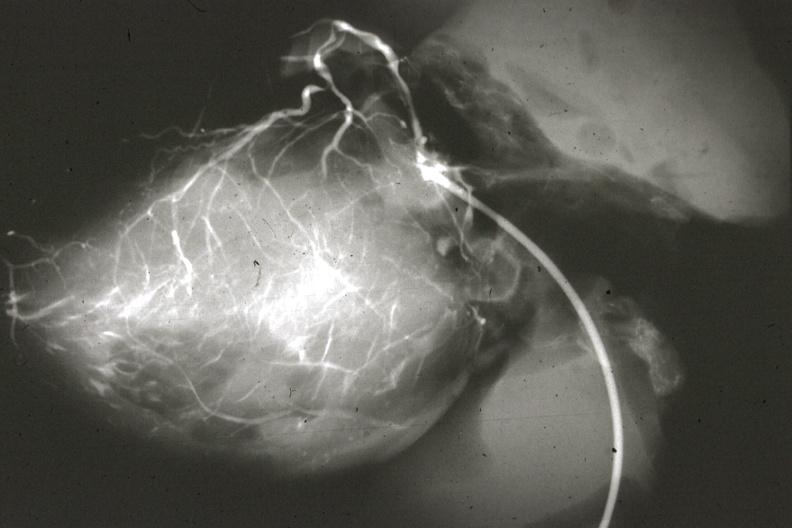s cardiovascular present?
Answer the question using a single word or phrase. Yes 